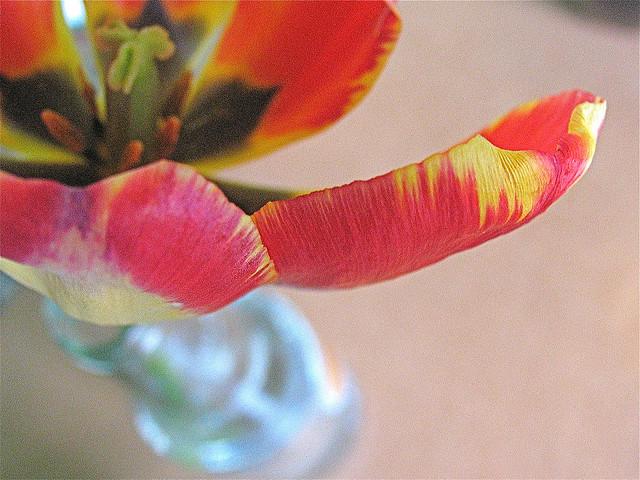Does this flower have 5 colors?
Concise answer only. Yes. What part of this image is food for bees?
Quick response, please. Pollen. What is the vase made of?
Quick response, please. Glass. 